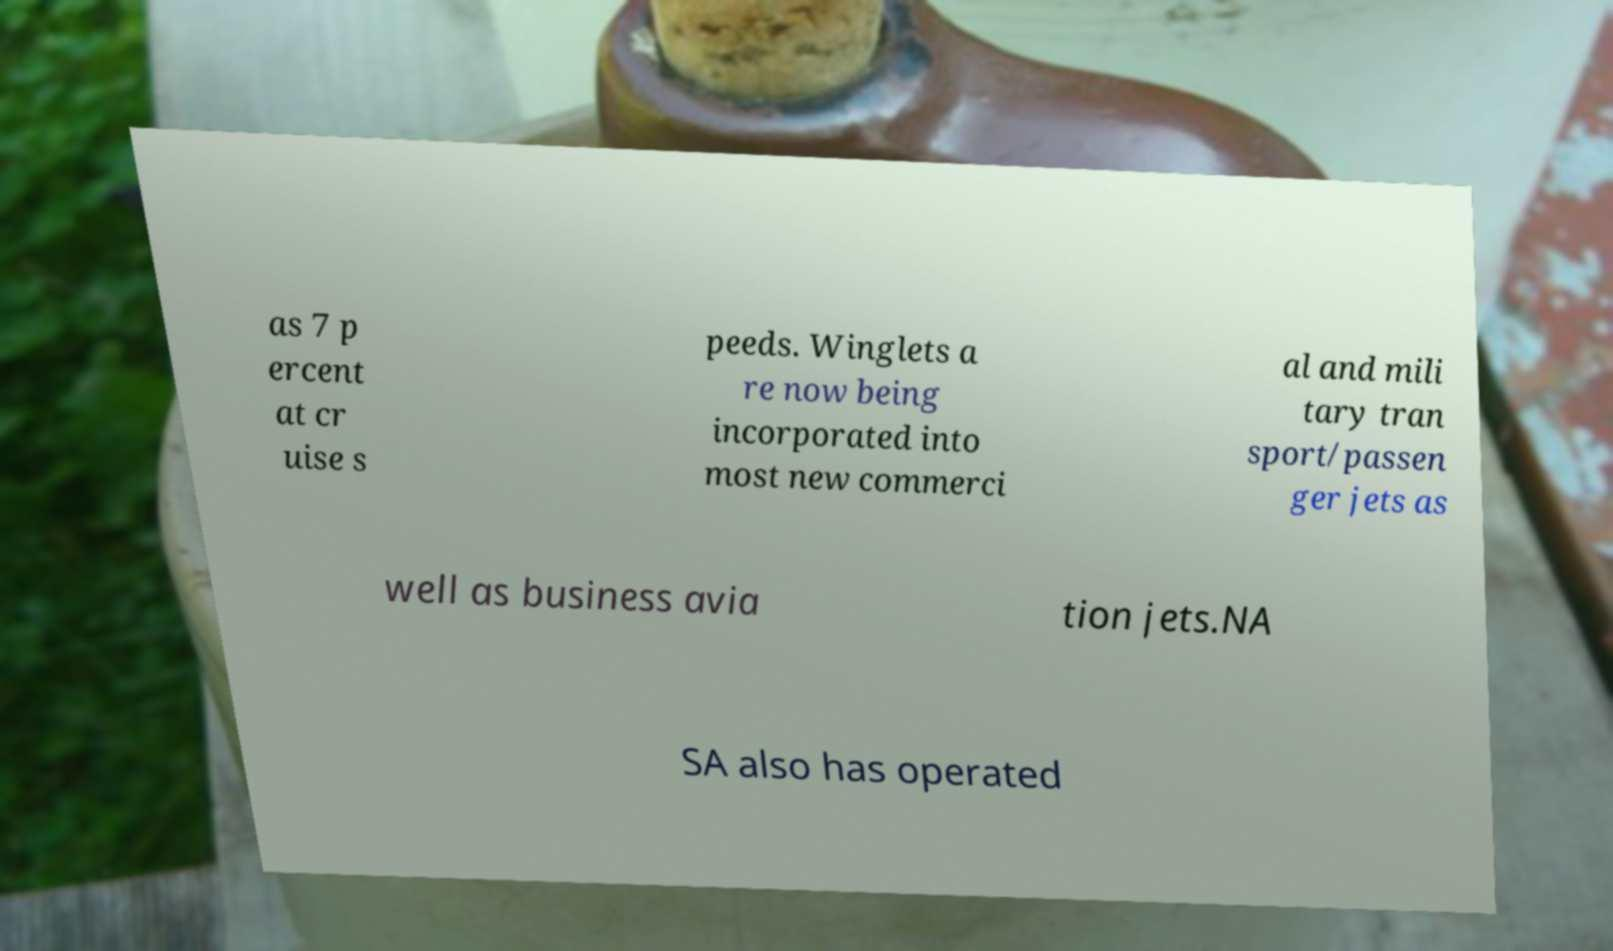Could you extract and type out the text from this image? as 7 p ercent at cr uise s peeds. Winglets a re now being incorporated into most new commerci al and mili tary tran sport/passen ger jets as well as business avia tion jets.NA SA also has operated 